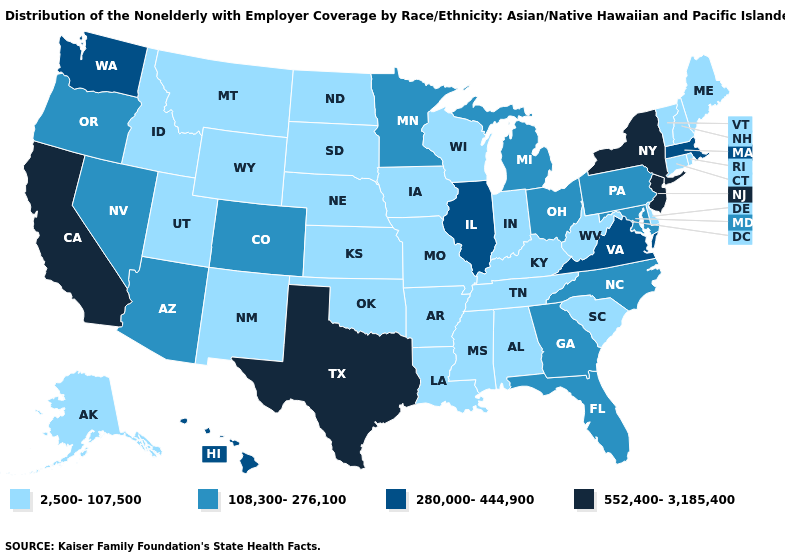What is the value of South Dakota?
Short answer required. 2,500-107,500. Does the map have missing data?
Keep it brief. No. What is the value of Alaska?
Quick response, please. 2,500-107,500. How many symbols are there in the legend?
Keep it brief. 4. Is the legend a continuous bar?
Answer briefly. No. Name the states that have a value in the range 108,300-276,100?
Quick response, please. Arizona, Colorado, Florida, Georgia, Maryland, Michigan, Minnesota, Nevada, North Carolina, Ohio, Oregon, Pennsylvania. What is the value of Maine?
Write a very short answer. 2,500-107,500. Does Oregon have the lowest value in the West?
Short answer required. No. Is the legend a continuous bar?
Short answer required. No. Among the states that border Alabama , does Georgia have the highest value?
Give a very brief answer. Yes. What is the value of Mississippi?
Be succinct. 2,500-107,500. Does New York have the highest value in the USA?
Quick response, please. Yes. What is the lowest value in states that border Alabama?
Short answer required. 2,500-107,500. What is the value of Nebraska?
Keep it brief. 2,500-107,500. Name the states that have a value in the range 552,400-3,185,400?
Write a very short answer. California, New Jersey, New York, Texas. 